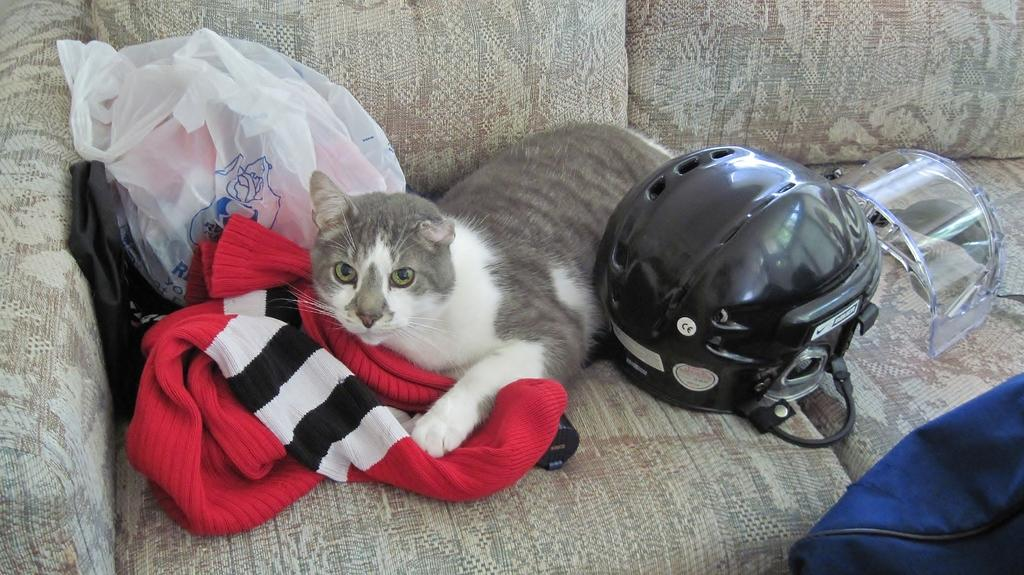What type of furniture is in the image? There is a couch in the image. What is placed on the couch? A helmet, a cat, and a sweater are present on the couch. What is covering the couch? Plastic covers are visible on the couch. Where is the bag located in the image? There is a bag in the bottom right corner of the image. What type of rock can be seen in the image? There is no rock present in the image. What kind of thing is the cat holding in the image? The cat is not holding anything in the image. 